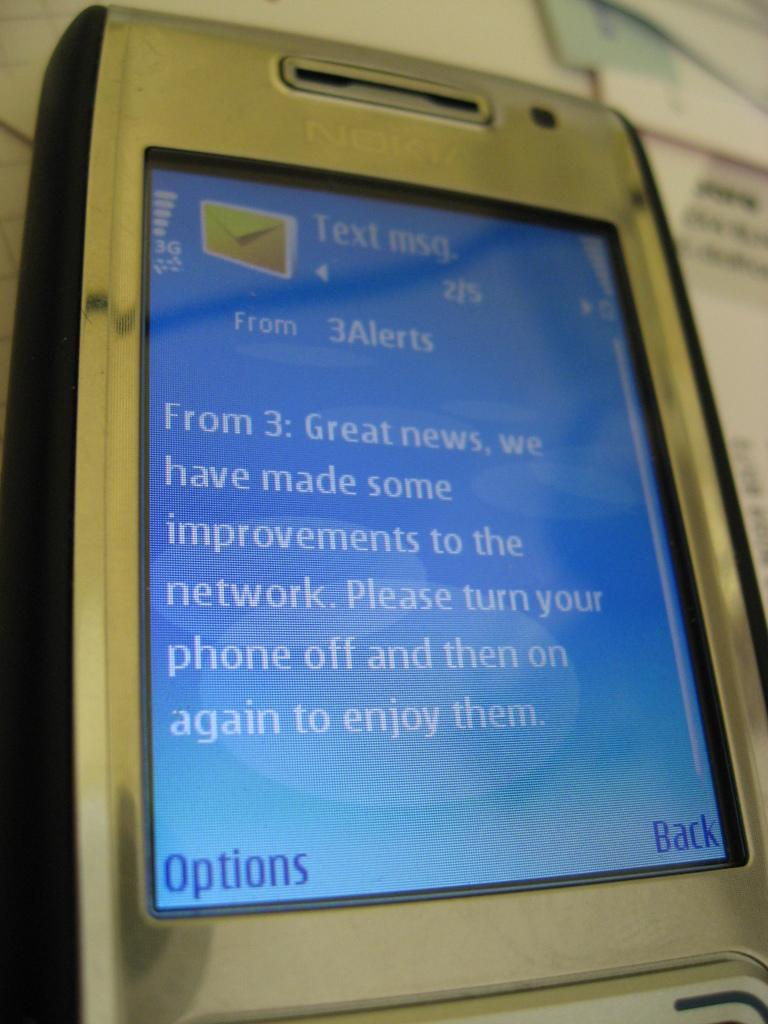Provide a one-sentence caption for the provided image. A nokia cellphone displays a text from 3Alerts. 